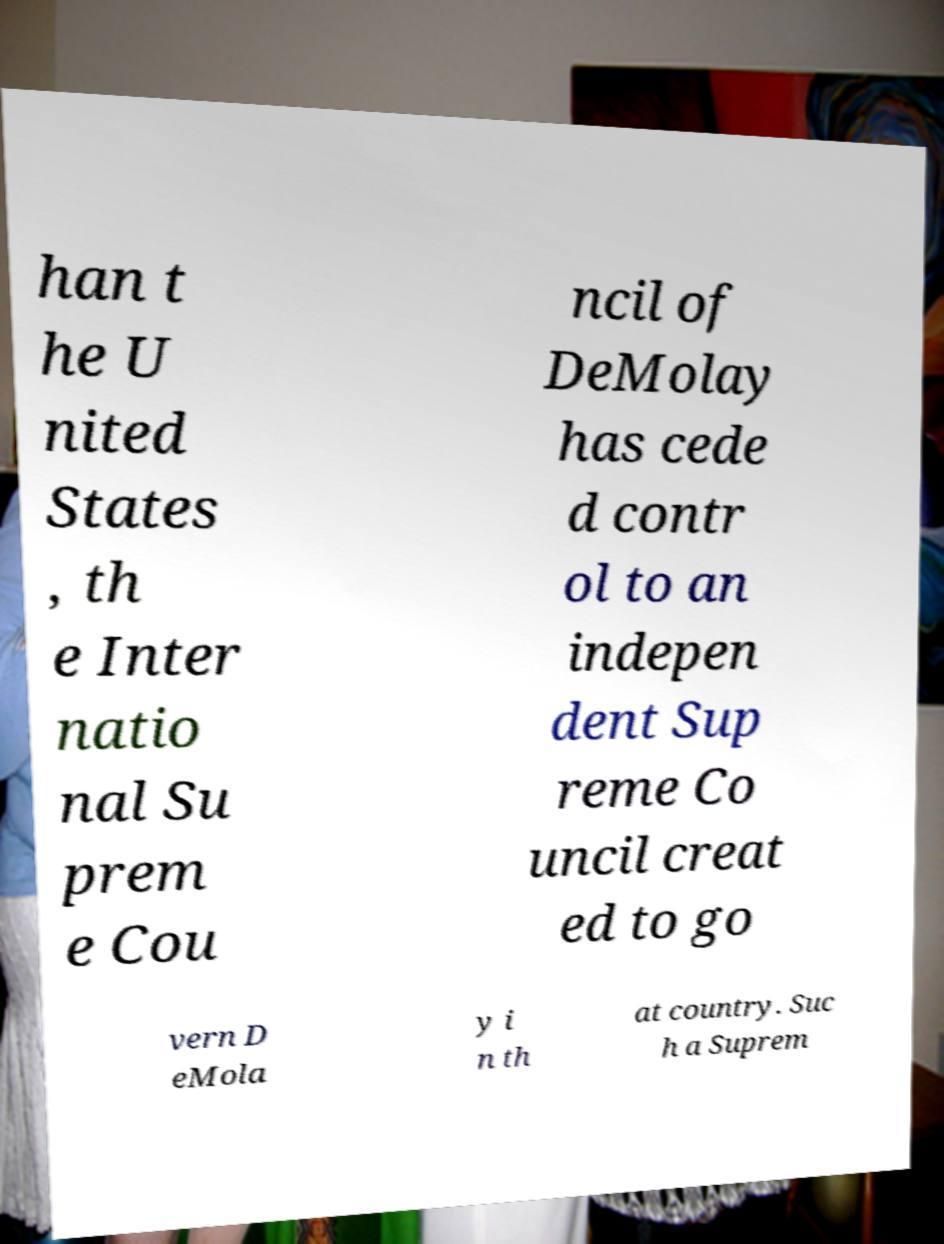Could you assist in decoding the text presented in this image and type it out clearly? han t he U nited States , th e Inter natio nal Su prem e Cou ncil of DeMolay has cede d contr ol to an indepen dent Sup reme Co uncil creat ed to go vern D eMola y i n th at country. Suc h a Suprem 